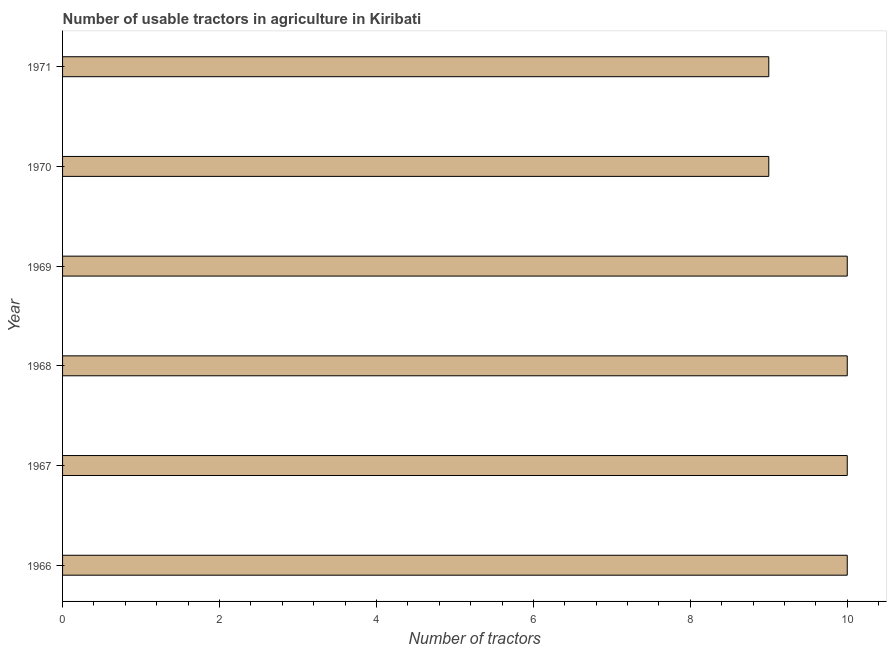Does the graph contain any zero values?
Your response must be concise. No. Does the graph contain grids?
Provide a short and direct response. No. What is the title of the graph?
Your answer should be compact. Number of usable tractors in agriculture in Kiribati. What is the label or title of the X-axis?
Your answer should be compact. Number of tractors. What is the label or title of the Y-axis?
Keep it short and to the point. Year. Across all years, what is the maximum number of tractors?
Your answer should be very brief. 10. In which year was the number of tractors maximum?
Make the answer very short. 1966. What is the average number of tractors per year?
Ensure brevity in your answer.  9. What is the median number of tractors?
Make the answer very short. 10. What is the ratio of the number of tractors in 1966 to that in 1970?
Ensure brevity in your answer.  1.11. What is the difference between the highest and the second highest number of tractors?
Offer a terse response. 0. Is the sum of the number of tractors in 1966 and 1969 greater than the maximum number of tractors across all years?
Your answer should be very brief. Yes. What is the difference between the highest and the lowest number of tractors?
Give a very brief answer. 1. Are all the bars in the graph horizontal?
Your answer should be very brief. Yes. How many years are there in the graph?
Make the answer very short. 6. What is the difference between two consecutive major ticks on the X-axis?
Your response must be concise. 2. Are the values on the major ticks of X-axis written in scientific E-notation?
Provide a short and direct response. No. What is the Number of tractors of 1969?
Provide a succinct answer. 10. What is the difference between the Number of tractors in 1966 and 1969?
Offer a very short reply. 0. What is the difference between the Number of tractors in 1966 and 1971?
Make the answer very short. 1. What is the difference between the Number of tractors in 1967 and 1968?
Give a very brief answer. 0. What is the difference between the Number of tractors in 1967 and 1970?
Provide a succinct answer. 1. What is the difference between the Number of tractors in 1967 and 1971?
Provide a succinct answer. 1. What is the difference between the Number of tractors in 1968 and 1971?
Provide a short and direct response. 1. What is the ratio of the Number of tractors in 1966 to that in 1969?
Your answer should be compact. 1. What is the ratio of the Number of tractors in 1966 to that in 1970?
Make the answer very short. 1.11. What is the ratio of the Number of tractors in 1966 to that in 1971?
Your answer should be very brief. 1.11. What is the ratio of the Number of tractors in 1967 to that in 1970?
Provide a short and direct response. 1.11. What is the ratio of the Number of tractors in 1967 to that in 1971?
Your answer should be very brief. 1.11. What is the ratio of the Number of tractors in 1968 to that in 1970?
Offer a very short reply. 1.11. What is the ratio of the Number of tractors in 1968 to that in 1971?
Offer a terse response. 1.11. What is the ratio of the Number of tractors in 1969 to that in 1970?
Your answer should be very brief. 1.11. What is the ratio of the Number of tractors in 1969 to that in 1971?
Make the answer very short. 1.11. 